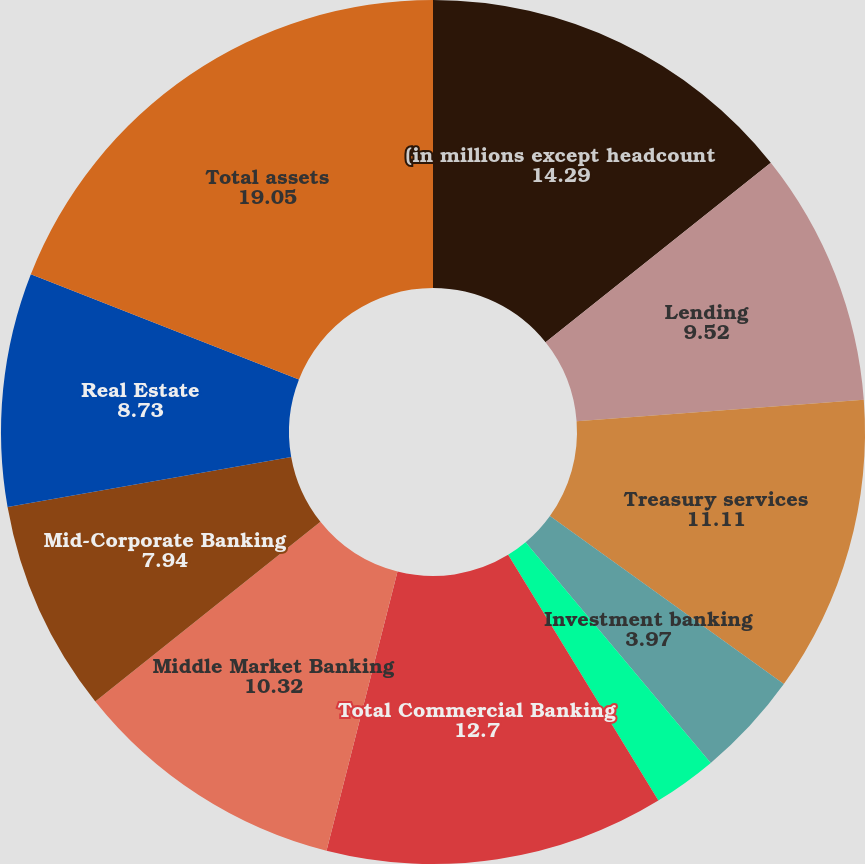<chart> <loc_0><loc_0><loc_500><loc_500><pie_chart><fcel>(in millions except headcount<fcel>Lending<fcel>Treasury services<fcel>Investment banking<fcel>Other<fcel>Total Commercial Banking<fcel>Middle Market Banking<fcel>Mid-Corporate Banking<fcel>Real Estate<fcel>Total assets<nl><fcel>14.29%<fcel>9.52%<fcel>11.11%<fcel>3.97%<fcel>2.38%<fcel>12.7%<fcel>10.32%<fcel>7.94%<fcel>8.73%<fcel>19.05%<nl></chart> 